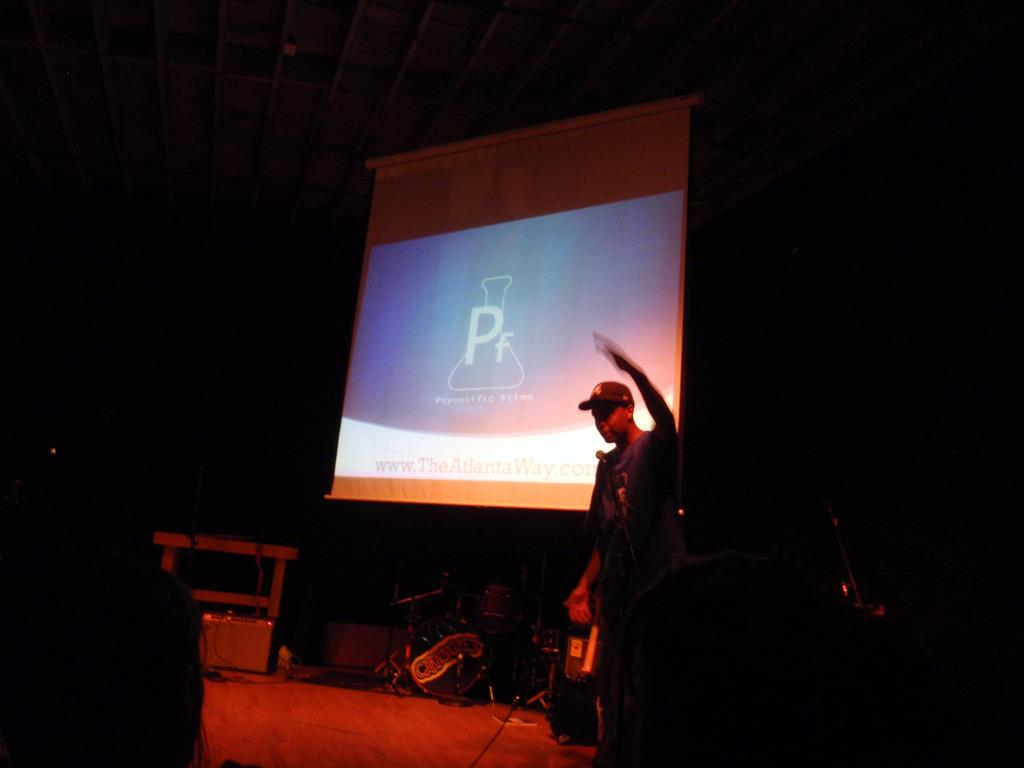What is the man in the image doing? The man is standing on the stage. What is the man using on the stage? The man is at a microphone. What can be seen in the background of the image? There are musical instruments and a screen in the background. How would you describe the overall appearance of the image? The image has a dark appearance. What type of insect can be seen crawling on the man's badge in the image? There is no insect or badge present in the image. 